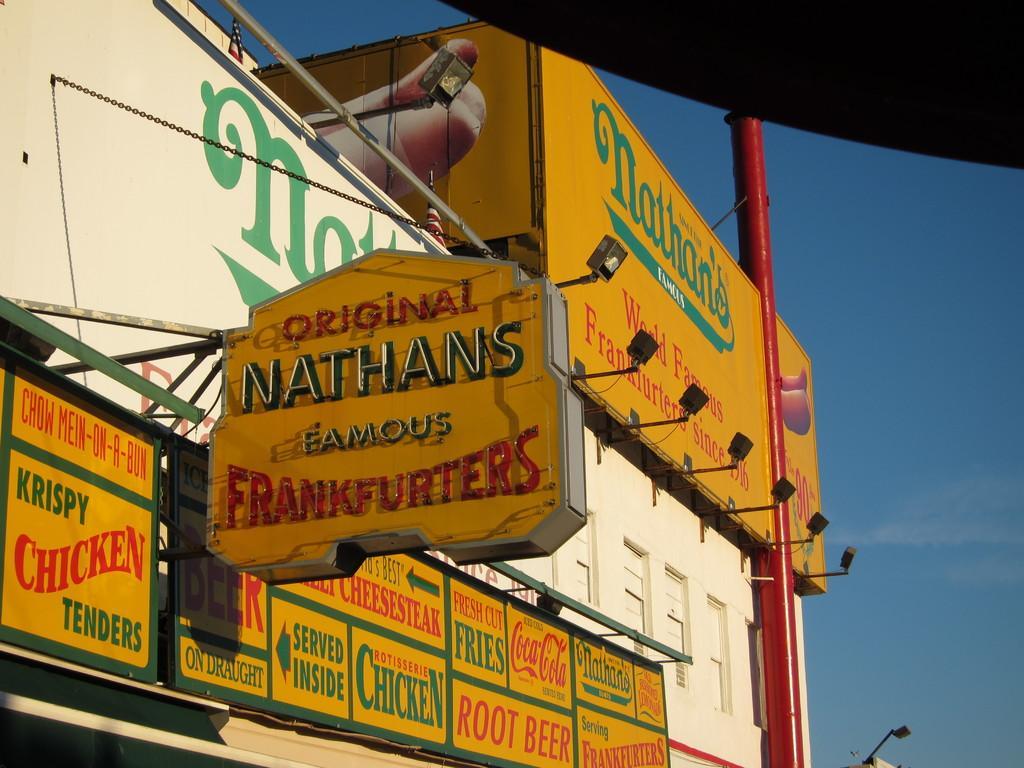In one or two sentences, can you explain what this image depicts? In this image we can see a building with windows. We can also see some lights, a pole, some chains, the signboards and a banner with some text on them. We can also see the sky which looks cloudy. 